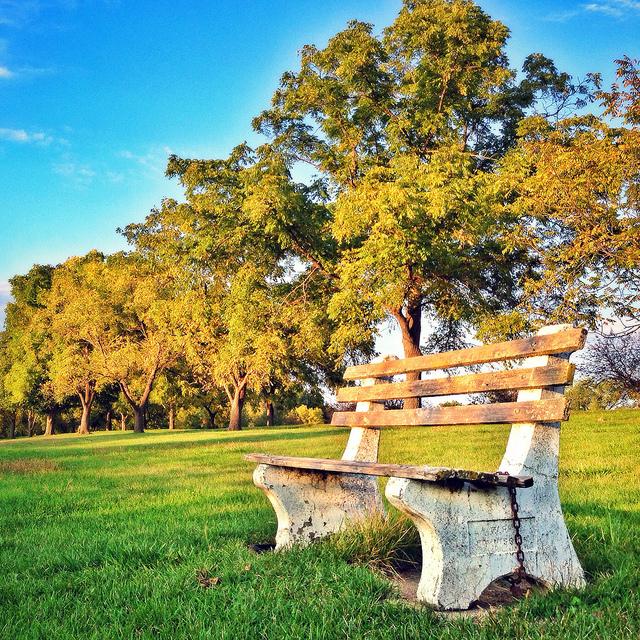Are there any animals in the forest?
Give a very brief answer. No. How many people are on the bench?
Short answer required. 0. What type of scenery is this?
Be succinct. Park. 